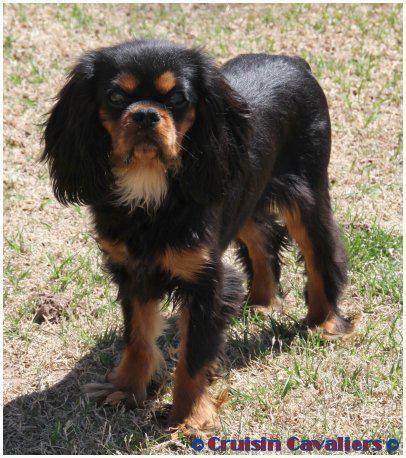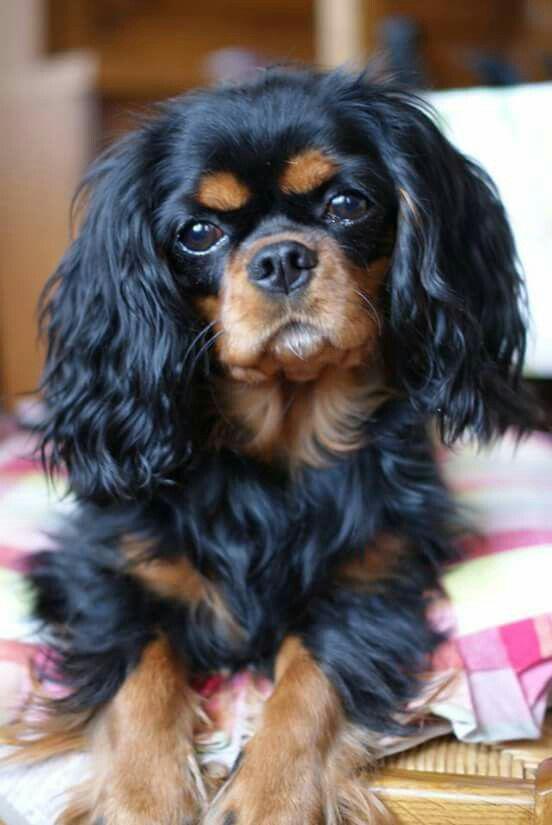The first image is the image on the left, the second image is the image on the right. Assess this claim about the two images: "The dog on the left is sitting on a wood surface.". Correct or not? Answer yes or no. No. The first image is the image on the left, the second image is the image on the right. Analyze the images presented: Is the assertion "An image features two similarly colored dogs posed next to each other." valid? Answer yes or no. No. The first image is the image on the left, the second image is the image on the right. Examine the images to the left and right. Is the description "There are three cocker spaniels" accurate? Answer yes or no. No. The first image is the image on the left, the second image is the image on the right. Assess this claim about the two images: "One image shows a black and brown spaniel standing and looking up at the camera.". Correct or not? Answer yes or no. Yes. 